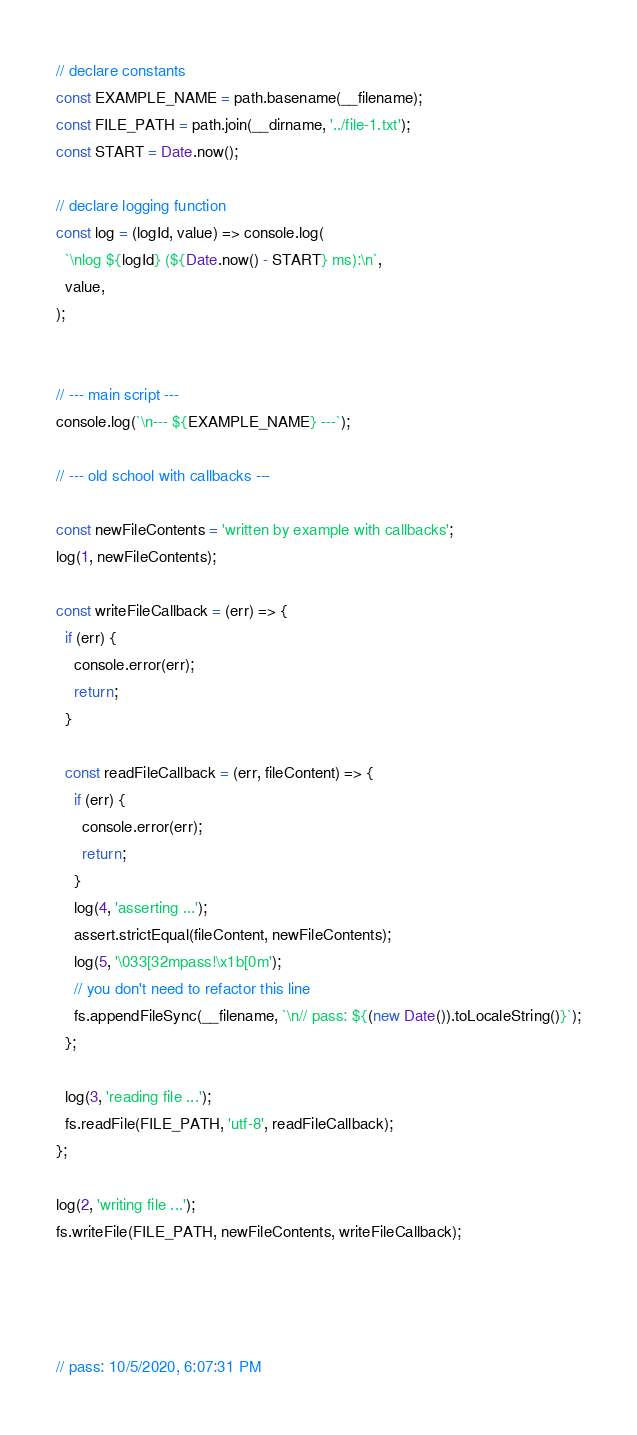Convert code to text. <code><loc_0><loc_0><loc_500><loc_500><_JavaScript_>
// declare constants
const EXAMPLE_NAME = path.basename(__filename);
const FILE_PATH = path.join(__dirname, '../file-1.txt');
const START = Date.now();

// declare logging function
const log = (logId, value) => console.log(
  `\nlog ${logId} (${Date.now() - START} ms):\n`,
  value,
);


// --- main script ---
console.log(`\n--- ${EXAMPLE_NAME} ---`);

// --- old school with callbacks ---

const newFileContents = 'written by example with callbacks';
log(1, newFileContents);

const writeFileCallback = (err) => {
  if (err) {
    console.error(err);
    return;
  }

  const readFileCallback = (err, fileContent) => {
    if (err) {
      console.error(err);
      return;
    }
    log(4, 'asserting ...');
    assert.strictEqual(fileContent, newFileContents);
    log(5, '\033[32mpass!\x1b[0m');
    // you don't need to refactor this line
    fs.appendFileSync(__filename, `\n// pass: ${(new Date()).toLocaleString()}`);
  };

  log(3, 'reading file ...');
  fs.readFile(FILE_PATH, 'utf-8', readFileCallback);
};

log(2, 'writing file ...');
fs.writeFile(FILE_PATH, newFileContents, writeFileCallback);




// pass: 10/5/2020, 6:07:31 PM
</code> 